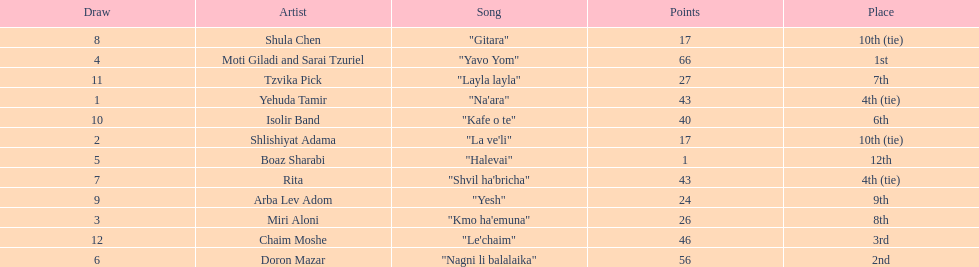Did the song "gitara" or "yesh" earn more points? "Yesh". 